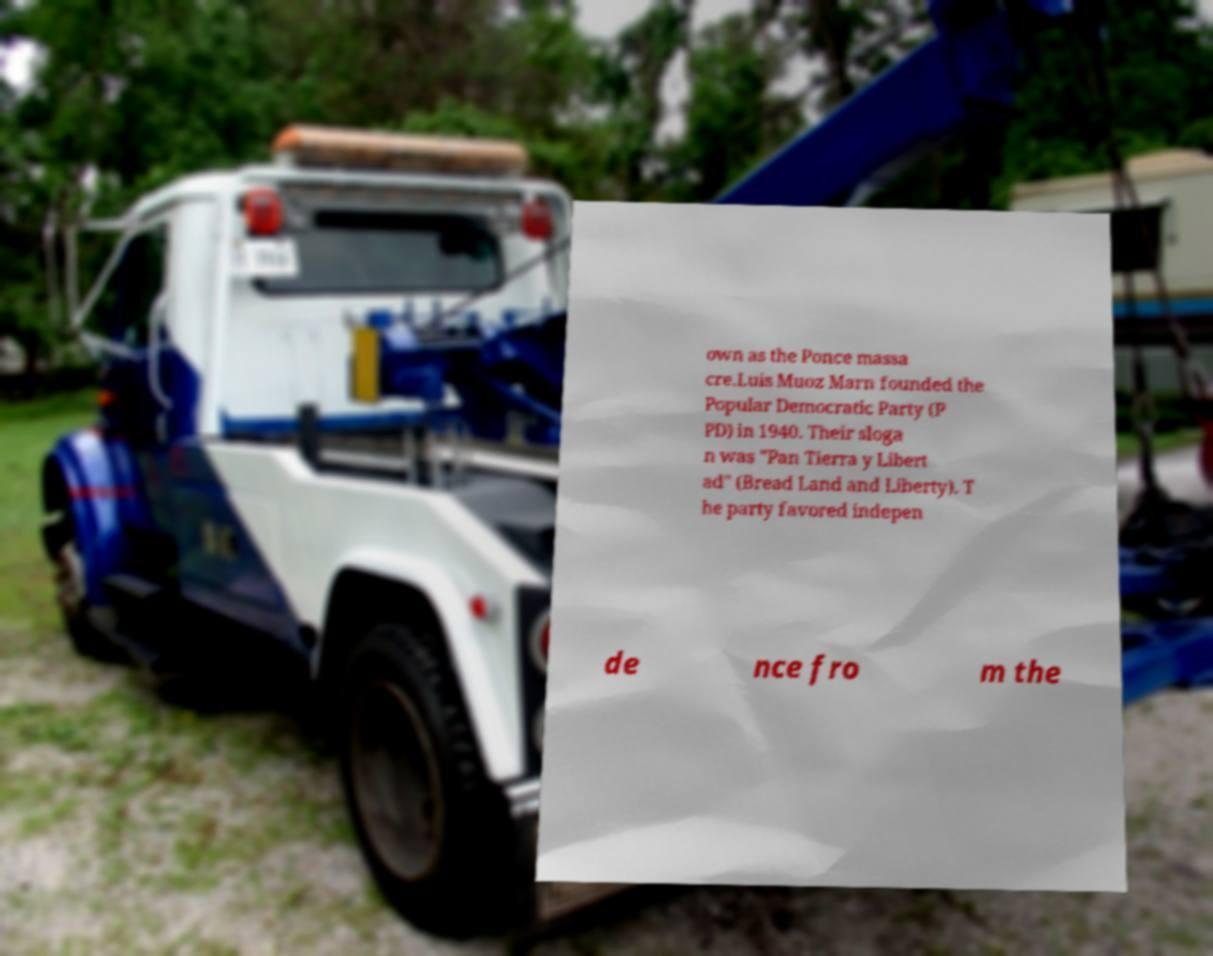Can you accurately transcribe the text from the provided image for me? own as the Ponce massa cre.Luis Muoz Marn founded the Popular Democratic Party (P PD) in 1940. Their sloga n was "Pan Tierra y Libert ad" (Bread Land and Liberty). T he party favored indepen de nce fro m the 